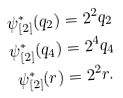<formula> <loc_0><loc_0><loc_500><loc_500>\psi ^ { * } _ { [ 2 ] } ( q _ { 2 } ) & = 2 ^ { 2 } q _ { 2 } \\ \psi ^ { * } _ { [ 2 ] } ( q _ { 4 } ) & = 2 ^ { 4 } q _ { 4 } \\ \psi ^ { * } _ { [ 2 ] } ( r ) & = 2 ^ { 2 } r .</formula> 